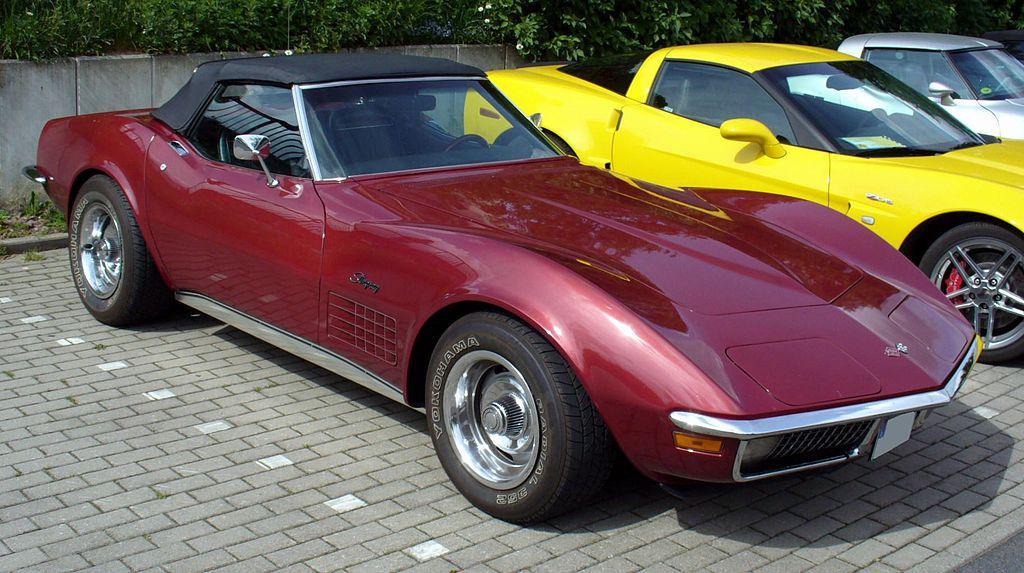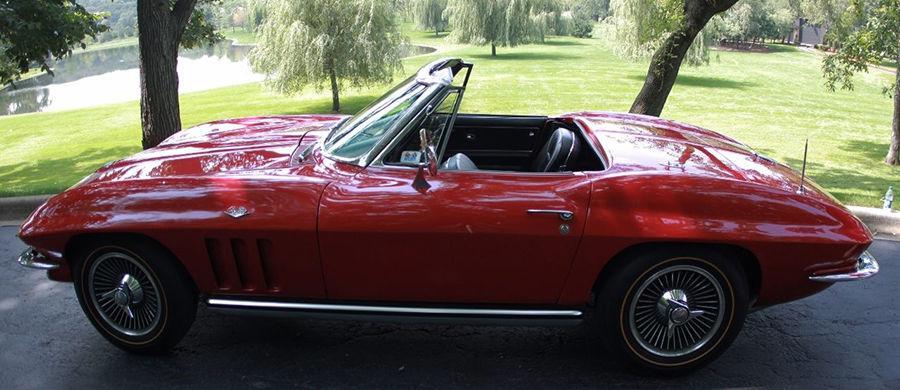The first image is the image on the left, the second image is the image on the right. Analyze the images presented: Is the assertion "The left image features a rightward-angled dark red convertible with its top covered, and the right image shows a leftward-facing dark red convertible with its top down." valid? Answer yes or no. Yes. 